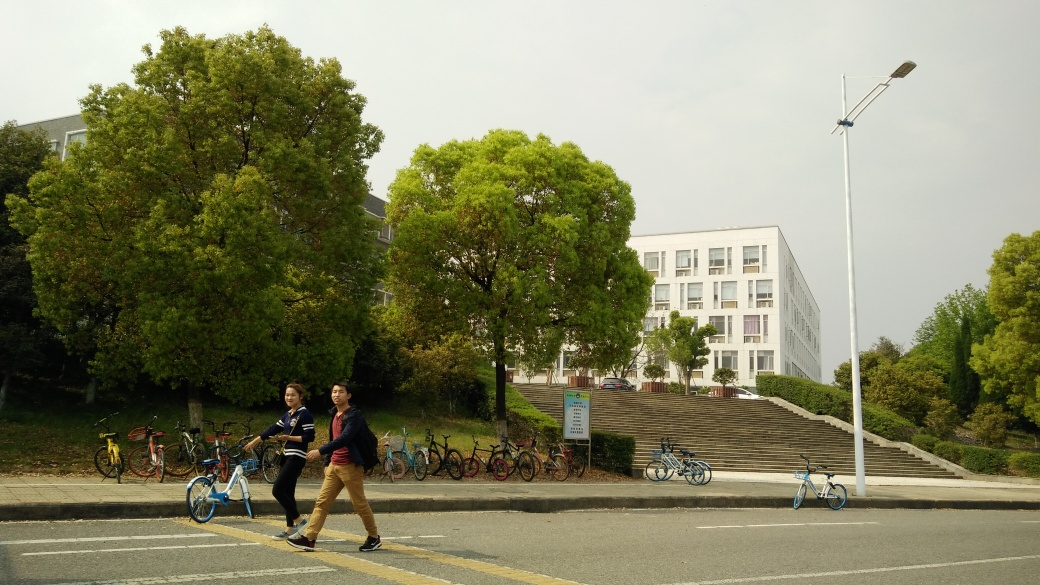What can you tell me about the architecture in this image? The architecture visible in the image features a modern building with a flat facade and symmetrically placed windows. This suggests a type of institutional or educational building, designed for functionality and practical use. 